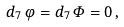Convert formula to latex. <formula><loc_0><loc_0><loc_500><loc_500>d _ { 7 } \, \varphi = d _ { 7 } \, \varPhi = 0 \, ,</formula> 